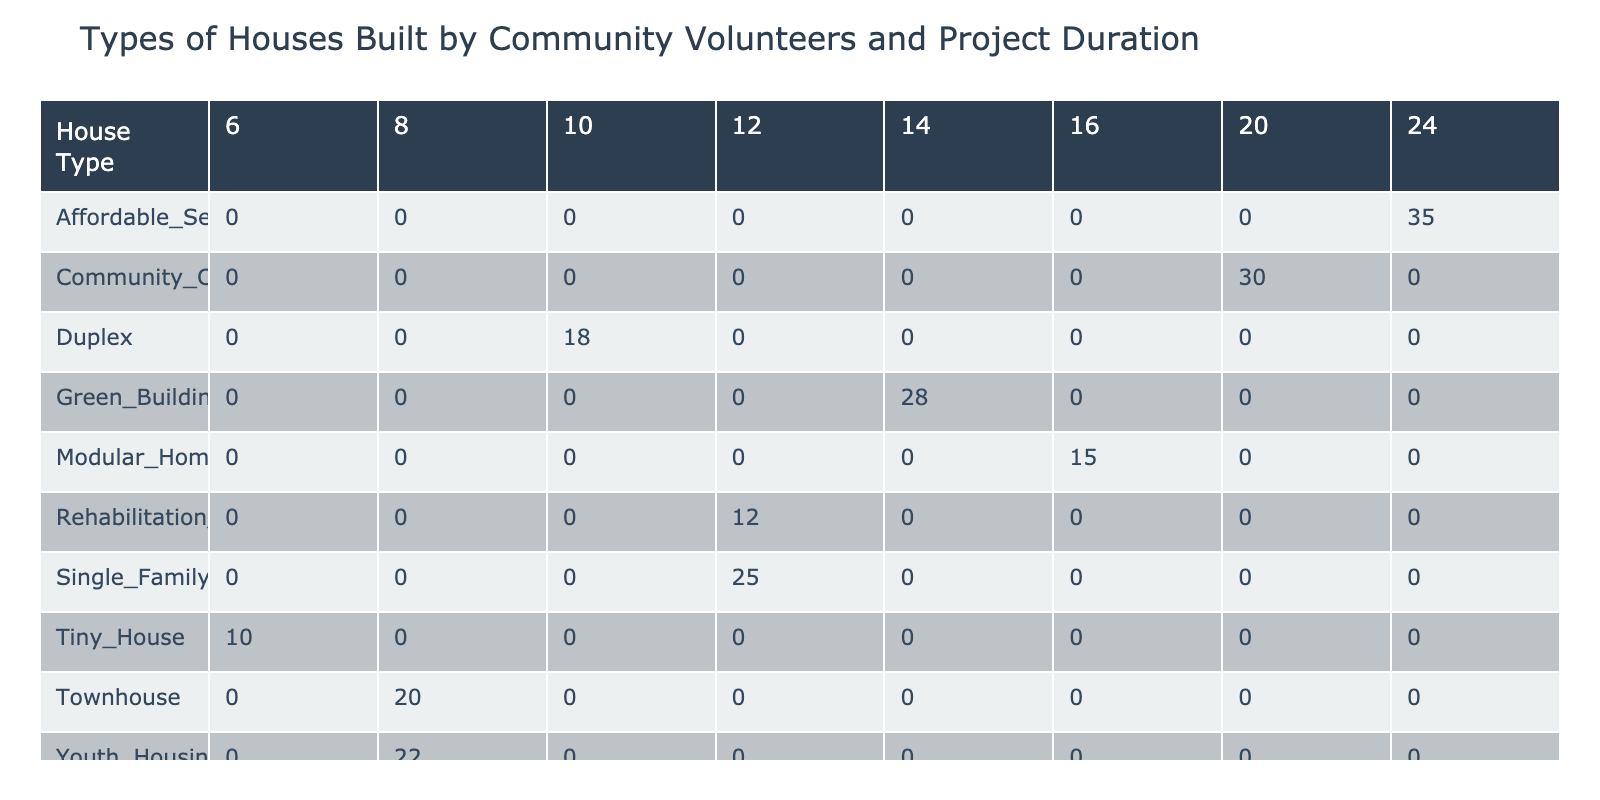What is the project duration for building a Tiny House? According to the table, the project duration for a Tiny House is listed under the "Project Duration Weeks" column, which shows that it takes 6 weeks to complete.
Answer: 6 weeks How many volunteers were involved in building the Community Center? Looking at the row for the Community Center in the Volunteer Count column, we find that 30 volunteers were involved in this project.
Answer: 30 volunteers What house type had the highest number of volunteers? By examining the Volunteer Count column, we see that the Affordable Seniors Apartment had the highest number of volunteers, which is 35.
Answer: Affordable Seniors Apartment What is the total number of volunteers involved in all projects combined? To find the total number of volunteers, I will sum all the values in the Volunteer Count column: 25 + 18 + 20 + 15 + 10 + 30 + 35 + 22 + 28 + 12 =  250.
Answer: 250 volunteers Is the project duration for a Duplex longer than that for a Tiny House? Comparing the durations, we see Duplex is listed with a duration of 10 weeks, while Tiny House is only 6 weeks, indicating that Duplex takes longer.
Answer: Yes What is the average project duration for all house types? First, I will sum the project durations: 12 + 10 + 8 + 16 + 6 + 20 + 24 + 8 + 14 + 12 =  120 weeks. There are 10 house types, so the average is 120/10 = 12 weeks.
Answer: 12 weeks How many more volunteers were involved in the Green Building Project compared to the Rehabilitation House? The Green Building Project had 28 volunteers and the Rehabilitation House had 12. To find the difference: 28 - 12 = 16. So, there were 16 more volunteers for the Green Building Project.
Answer: 16 more volunteers Which house type has the shortest project duration and how many volunteers did it have? Reviewing the table, the Tiny House has the shortest project duration of 6 weeks and it involved 10 volunteers.
Answer: Tiny House, 10 volunteers Is it true that all house types require project durations less than 30 weeks? Looking at all the project durations listed, they all fall below 30 weeks, confirming that the statement is true.
Answer: Yes 